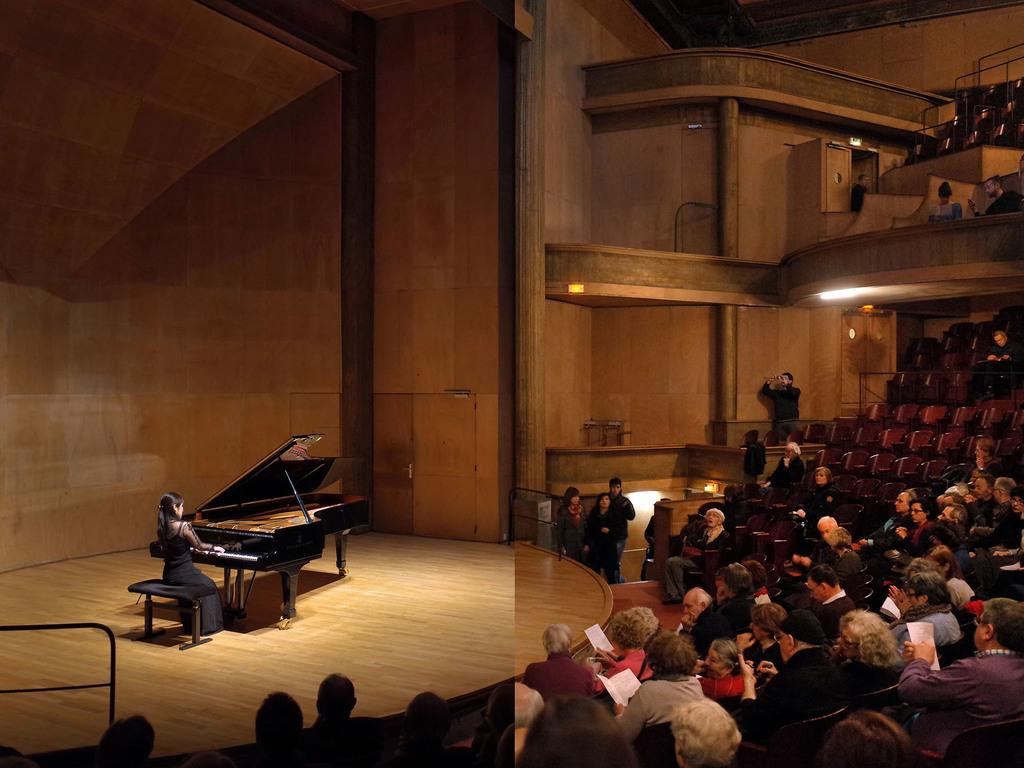What is happening on the right side of the image? There are many people sitting on the right side of the image. What are the people doing? The people are watching a performance. What can be seen on the stage during the performance? There is a lady playing a piano on the stage. How many pies are being served to the audience in the image? There is no mention of pies being served in the image; the people are watching a performance with a lady playing a piano on stage. What color are the toes of the lady playing the piano? The image does not show the lady's toes, so we cannot determine their color. 